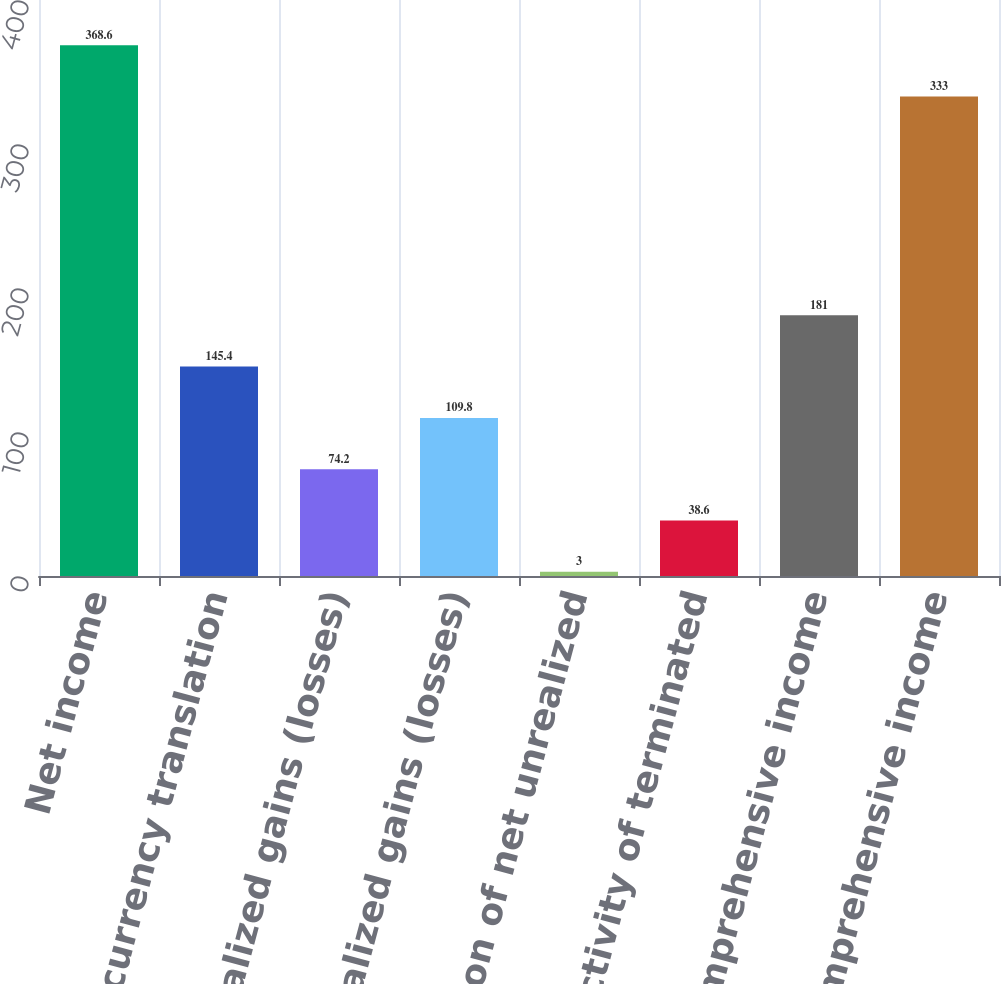Convert chart. <chart><loc_0><loc_0><loc_500><loc_500><bar_chart><fcel>Net income<fcel>Foreign currency translation<fcel>Unrealized gains (losses)<fcel>Net unrealized gains (losses)<fcel>Amortization of net unrealized<fcel>Net activity of terminated<fcel>Other comprehensive income<fcel>Comprehensive income<nl><fcel>368.6<fcel>145.4<fcel>74.2<fcel>109.8<fcel>3<fcel>38.6<fcel>181<fcel>333<nl></chart> 